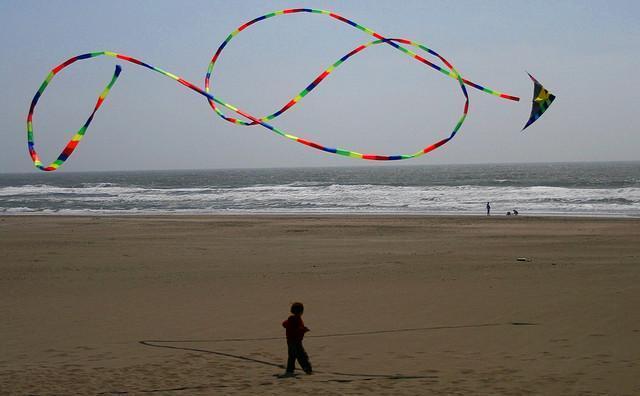How many people are on the ski lift?
Give a very brief answer. 0. 